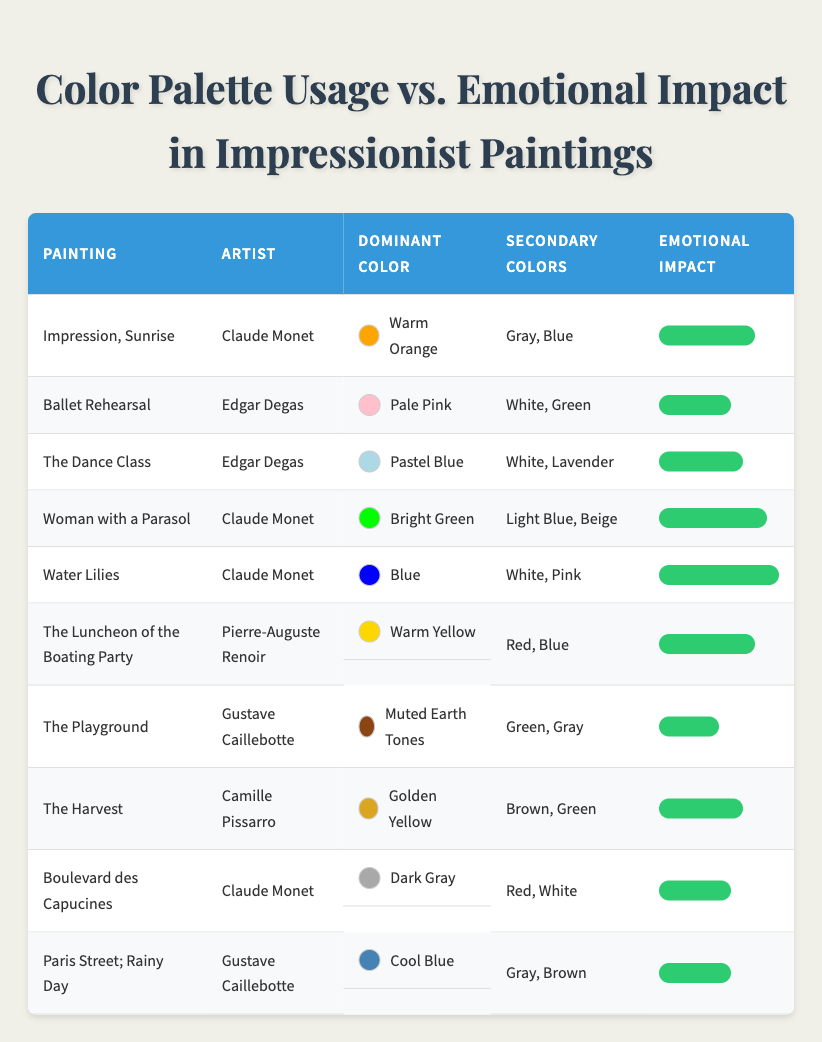What is the dominant color used in "Water Lilies"? The table shows that the dominant color for "Water Lilies" is listed under the relevant column, which states "Blue."
Answer: Blue Which painting has the highest emotional impact rating? By scanning the emotional impact column, "Water Lilies" has the highest rating of 10, which is noted in the fifth row.
Answer: Water Lilies What is the average emotional impact of paintings by Claude Monet? Claude Monet has three paintings in the table: "Impression, Sunrise" (8), "Woman with a Parasol" (9), and "Water Lilies" (10). The sum is 8 + 9 + 10 = 27. Dividing by 3 gives an average of 27 / 3 = 9.
Answer: 9 Is it true that all paintings with warm colors have a higher emotional impact than those with cool colors? Examining the table reveals that "Impression, Sunrise" (8, Warm Orange), "The Luncheon of the Boating Party" (8, Warm Yellow), and "Water Lilies" (10, Blue, with a lower emotional impact than the warm color paintings). Thus, the statement is not true since "Water Lilies" has a higher emotional impact despite being a cool color.
Answer: No Which secondary color appears most frequently across the paintings? By reviewing the secondary colors for all paintings, Gray appears in "Impression, Sunrise," "Boulevard des Capucines," and "Paris Street; Rainy Day," totaling three paintings, which is more than any other secondary color.
Answer: Gray What emotional impact rating difference is observed between the painting with the lowest impact and the one with the highest? The lowest emotional impact is from "The Playground" with a rating of 5, and the highest is "Water Lilies" with a rating of 10. The difference is calculated as 10 - 5 = 5.
Answer: 5 How many paintings feature Bright Green as the dominant color? Looking through the table, "Woman with a Parasol" is the only painting where Bright Green is the dominant color, indicated in the fourth row.
Answer: 1 Are there more paintings with pastel colors or muted colors as the dominant color? From the table, we see "The Dance Class" and "Ballet Rehearsal" with pastel colors and only "The Playground" for muted colors, making it three versus one. Therefore, there are more paintings with pastel colors.
Answer: Yes Which artist has the lowest average emotional impact in the table? Examining each artist: Edgar Degas has two paintings ("Ballet Rehearsal" (6) and "The Dance Class" (7), which sum to 13, averaging 6.5), while Gustave Caillebotte has two paintings with scores of 5 and 6, totaling 11 for an average of 5.5. Therefore, Gustave Caillebotte has the lowest average.
Answer: Gustave Caillebotte 